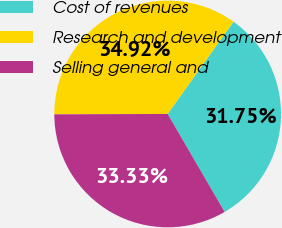<chart> <loc_0><loc_0><loc_500><loc_500><pie_chart><fcel>Cost of revenues<fcel>Research and development<fcel>Selling general and<nl><fcel>31.75%<fcel>34.92%<fcel>33.33%<nl></chart> 